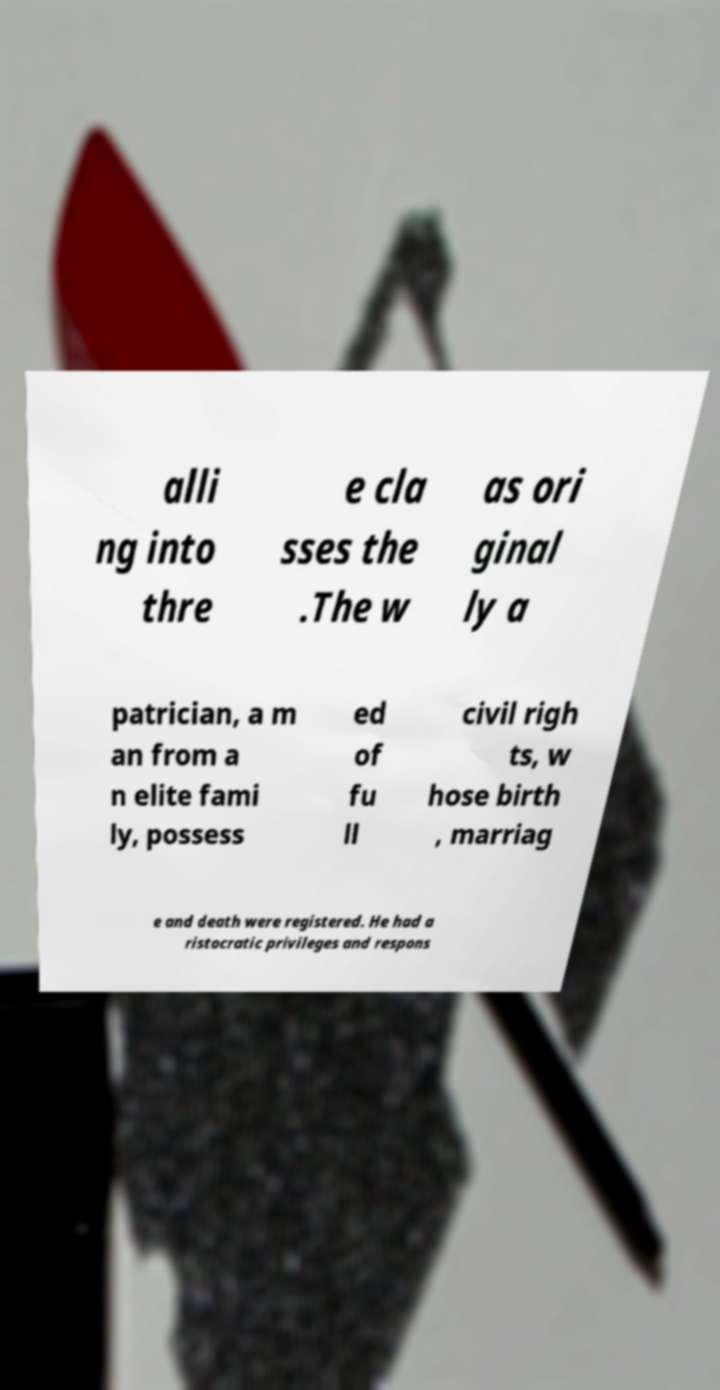There's text embedded in this image that I need extracted. Can you transcribe it verbatim? alli ng into thre e cla sses the .The w as ori ginal ly a patrician, a m an from a n elite fami ly, possess ed of fu ll civil righ ts, w hose birth , marriag e and death were registered. He had a ristocratic privileges and respons 